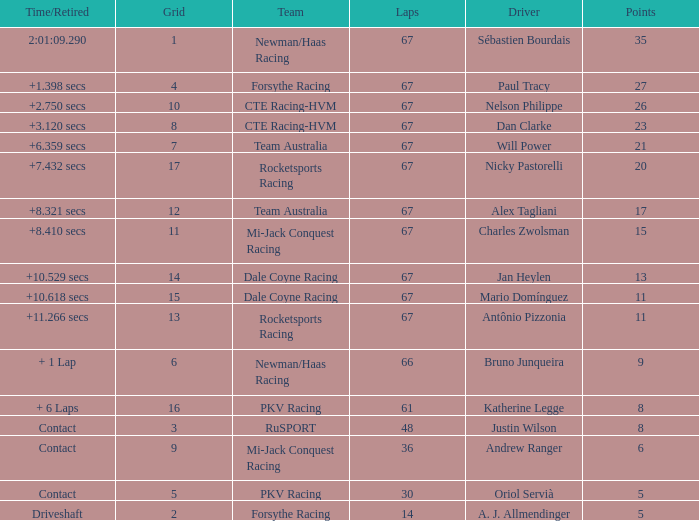What was time/retired with less than 67 laps and 6 points? Contact. Can you give me this table as a dict? {'header': ['Time/Retired', 'Grid', 'Team', 'Laps', 'Driver', 'Points'], 'rows': [['2:01:09.290', '1', 'Newman/Haas Racing', '67', 'Sébastien Bourdais', '35'], ['+1.398 secs', '4', 'Forsythe Racing', '67', 'Paul Tracy', '27'], ['+2.750 secs', '10', 'CTE Racing-HVM', '67', 'Nelson Philippe', '26'], ['+3.120 secs', '8', 'CTE Racing-HVM', '67', 'Dan Clarke', '23'], ['+6.359 secs', '7', 'Team Australia', '67', 'Will Power', '21'], ['+7.432 secs', '17', 'Rocketsports Racing', '67', 'Nicky Pastorelli', '20'], ['+8.321 secs', '12', 'Team Australia', '67', 'Alex Tagliani', '17'], ['+8.410 secs', '11', 'Mi-Jack Conquest Racing', '67', 'Charles Zwolsman', '15'], ['+10.529 secs', '14', 'Dale Coyne Racing', '67', 'Jan Heylen', '13'], ['+10.618 secs', '15', 'Dale Coyne Racing', '67', 'Mario Domínguez', '11'], ['+11.266 secs', '13', 'Rocketsports Racing', '67', 'Antônio Pizzonia', '11'], ['+ 1 Lap', '6', 'Newman/Haas Racing', '66', 'Bruno Junqueira', '9'], ['+ 6 Laps', '16', 'PKV Racing', '61', 'Katherine Legge', '8'], ['Contact', '3', 'RuSPORT', '48', 'Justin Wilson', '8'], ['Contact', '9', 'Mi-Jack Conquest Racing', '36', 'Andrew Ranger', '6'], ['Contact', '5', 'PKV Racing', '30', 'Oriol Servià', '5'], ['Driveshaft', '2', 'Forsythe Racing', '14', 'A. J. Allmendinger', '5']]} 